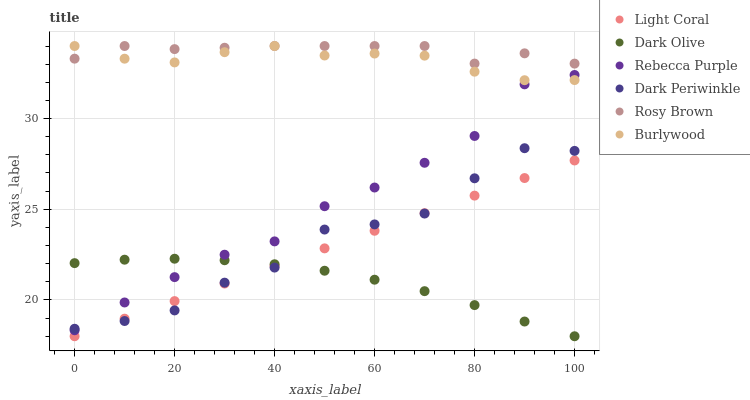Does Dark Olive have the minimum area under the curve?
Answer yes or no. Yes. Does Rosy Brown have the maximum area under the curve?
Answer yes or no. Yes. Does Burlywood have the minimum area under the curve?
Answer yes or no. No. Does Burlywood have the maximum area under the curve?
Answer yes or no. No. Is Light Coral the smoothest?
Answer yes or no. Yes. Is Dark Periwinkle the roughest?
Answer yes or no. Yes. Is Burlywood the smoothest?
Answer yes or no. No. Is Burlywood the roughest?
Answer yes or no. No. Does Dark Olive have the lowest value?
Answer yes or no. Yes. Does Burlywood have the lowest value?
Answer yes or no. No. Does Rosy Brown have the highest value?
Answer yes or no. Yes. Does Light Coral have the highest value?
Answer yes or no. No. Is Dark Olive less than Burlywood?
Answer yes or no. Yes. Is Rosy Brown greater than Dark Periwinkle?
Answer yes or no. Yes. Does Dark Periwinkle intersect Rebecca Purple?
Answer yes or no. Yes. Is Dark Periwinkle less than Rebecca Purple?
Answer yes or no. No. Is Dark Periwinkle greater than Rebecca Purple?
Answer yes or no. No. Does Dark Olive intersect Burlywood?
Answer yes or no. No. 